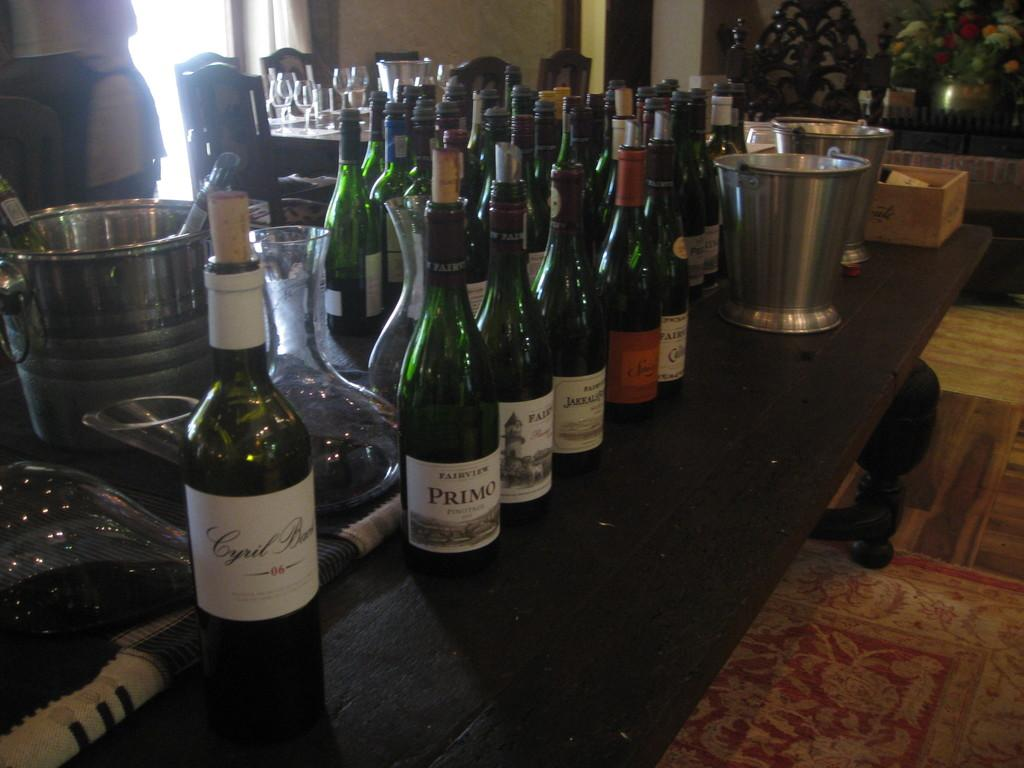<image>
Render a clear and concise summary of the photo. A bottle of Primo wine is next to another bottle with the word Faik on the label. 